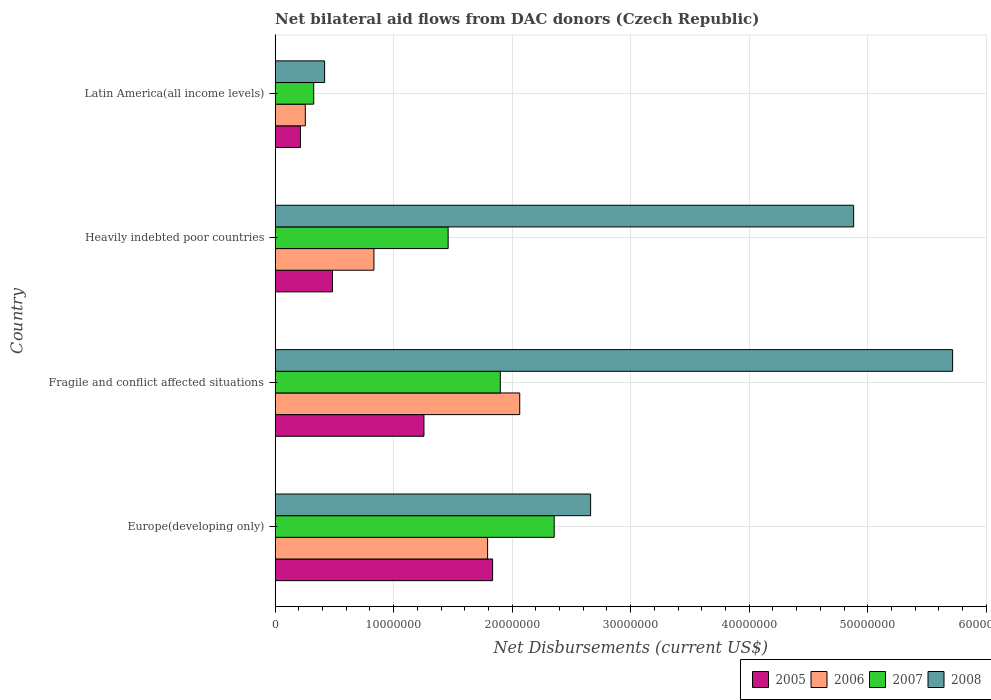Are the number of bars on each tick of the Y-axis equal?
Your answer should be very brief. Yes. How many bars are there on the 2nd tick from the top?
Your answer should be very brief. 4. How many bars are there on the 3rd tick from the bottom?
Your response must be concise. 4. What is the label of the 4th group of bars from the top?
Ensure brevity in your answer.  Europe(developing only). What is the net bilateral aid flows in 2005 in Fragile and conflict affected situations?
Make the answer very short. 1.26e+07. Across all countries, what is the maximum net bilateral aid flows in 2008?
Your response must be concise. 5.72e+07. Across all countries, what is the minimum net bilateral aid flows in 2006?
Your response must be concise. 2.55e+06. In which country was the net bilateral aid flows in 2007 maximum?
Make the answer very short. Europe(developing only). In which country was the net bilateral aid flows in 2007 minimum?
Offer a terse response. Latin America(all income levels). What is the total net bilateral aid flows in 2008 in the graph?
Provide a succinct answer. 1.37e+08. What is the difference between the net bilateral aid flows in 2005 in Fragile and conflict affected situations and that in Heavily indebted poor countries?
Keep it short and to the point. 7.72e+06. What is the difference between the net bilateral aid flows in 2005 in Heavily indebted poor countries and the net bilateral aid flows in 2008 in Fragile and conflict affected situations?
Offer a terse response. -5.23e+07. What is the average net bilateral aid flows in 2008 per country?
Offer a terse response. 3.42e+07. What is the difference between the net bilateral aid flows in 2007 and net bilateral aid flows in 2006 in Latin America(all income levels)?
Provide a succinct answer. 7.10e+05. What is the ratio of the net bilateral aid flows in 2007 in Europe(developing only) to that in Latin America(all income levels)?
Your response must be concise. 7.22. Is the net bilateral aid flows in 2008 in Fragile and conflict affected situations less than that in Latin America(all income levels)?
Ensure brevity in your answer.  No. What is the difference between the highest and the second highest net bilateral aid flows in 2007?
Make the answer very short. 4.55e+06. What is the difference between the highest and the lowest net bilateral aid flows in 2008?
Your answer should be compact. 5.30e+07. Is the sum of the net bilateral aid flows in 2005 in Fragile and conflict affected situations and Heavily indebted poor countries greater than the maximum net bilateral aid flows in 2007 across all countries?
Keep it short and to the point. No. Is it the case that in every country, the sum of the net bilateral aid flows in 2008 and net bilateral aid flows in 2007 is greater than the sum of net bilateral aid flows in 2005 and net bilateral aid flows in 2006?
Offer a very short reply. No. How many bars are there?
Ensure brevity in your answer.  16. Does the graph contain any zero values?
Your answer should be compact. No. Where does the legend appear in the graph?
Keep it short and to the point. Bottom right. How many legend labels are there?
Keep it short and to the point. 4. How are the legend labels stacked?
Provide a short and direct response. Horizontal. What is the title of the graph?
Offer a very short reply. Net bilateral aid flows from DAC donors (Czech Republic). Does "2008" appear as one of the legend labels in the graph?
Your answer should be very brief. Yes. What is the label or title of the X-axis?
Ensure brevity in your answer.  Net Disbursements (current US$). What is the Net Disbursements (current US$) in 2005 in Europe(developing only)?
Provide a succinct answer. 1.84e+07. What is the Net Disbursements (current US$) of 2006 in Europe(developing only)?
Provide a short and direct response. 1.79e+07. What is the Net Disbursements (current US$) in 2007 in Europe(developing only)?
Your answer should be compact. 2.36e+07. What is the Net Disbursements (current US$) of 2008 in Europe(developing only)?
Your answer should be very brief. 2.66e+07. What is the Net Disbursements (current US$) of 2005 in Fragile and conflict affected situations?
Your response must be concise. 1.26e+07. What is the Net Disbursements (current US$) of 2006 in Fragile and conflict affected situations?
Keep it short and to the point. 2.06e+07. What is the Net Disbursements (current US$) in 2007 in Fragile and conflict affected situations?
Provide a short and direct response. 1.90e+07. What is the Net Disbursements (current US$) in 2008 in Fragile and conflict affected situations?
Your answer should be compact. 5.72e+07. What is the Net Disbursements (current US$) of 2005 in Heavily indebted poor countries?
Ensure brevity in your answer.  4.84e+06. What is the Net Disbursements (current US$) of 2006 in Heavily indebted poor countries?
Ensure brevity in your answer.  8.34e+06. What is the Net Disbursements (current US$) of 2007 in Heavily indebted poor countries?
Your response must be concise. 1.46e+07. What is the Net Disbursements (current US$) in 2008 in Heavily indebted poor countries?
Keep it short and to the point. 4.88e+07. What is the Net Disbursements (current US$) of 2005 in Latin America(all income levels)?
Your response must be concise. 2.14e+06. What is the Net Disbursements (current US$) in 2006 in Latin America(all income levels)?
Offer a very short reply. 2.55e+06. What is the Net Disbursements (current US$) in 2007 in Latin America(all income levels)?
Ensure brevity in your answer.  3.26e+06. What is the Net Disbursements (current US$) of 2008 in Latin America(all income levels)?
Provide a succinct answer. 4.18e+06. Across all countries, what is the maximum Net Disbursements (current US$) in 2005?
Provide a succinct answer. 1.84e+07. Across all countries, what is the maximum Net Disbursements (current US$) of 2006?
Provide a succinct answer. 2.06e+07. Across all countries, what is the maximum Net Disbursements (current US$) in 2007?
Keep it short and to the point. 2.36e+07. Across all countries, what is the maximum Net Disbursements (current US$) of 2008?
Provide a short and direct response. 5.72e+07. Across all countries, what is the minimum Net Disbursements (current US$) of 2005?
Make the answer very short. 2.14e+06. Across all countries, what is the minimum Net Disbursements (current US$) in 2006?
Provide a short and direct response. 2.55e+06. Across all countries, what is the minimum Net Disbursements (current US$) of 2007?
Provide a short and direct response. 3.26e+06. Across all countries, what is the minimum Net Disbursements (current US$) in 2008?
Give a very brief answer. 4.18e+06. What is the total Net Disbursements (current US$) in 2005 in the graph?
Give a very brief answer. 3.79e+07. What is the total Net Disbursements (current US$) in 2006 in the graph?
Provide a succinct answer. 4.95e+07. What is the total Net Disbursements (current US$) in 2007 in the graph?
Provide a succinct answer. 6.04e+07. What is the total Net Disbursements (current US$) in 2008 in the graph?
Provide a succinct answer. 1.37e+08. What is the difference between the Net Disbursements (current US$) of 2005 in Europe(developing only) and that in Fragile and conflict affected situations?
Offer a terse response. 5.79e+06. What is the difference between the Net Disbursements (current US$) in 2006 in Europe(developing only) and that in Fragile and conflict affected situations?
Your answer should be compact. -2.71e+06. What is the difference between the Net Disbursements (current US$) in 2007 in Europe(developing only) and that in Fragile and conflict affected situations?
Your response must be concise. 4.55e+06. What is the difference between the Net Disbursements (current US$) of 2008 in Europe(developing only) and that in Fragile and conflict affected situations?
Keep it short and to the point. -3.05e+07. What is the difference between the Net Disbursements (current US$) in 2005 in Europe(developing only) and that in Heavily indebted poor countries?
Offer a very short reply. 1.35e+07. What is the difference between the Net Disbursements (current US$) in 2006 in Europe(developing only) and that in Heavily indebted poor countries?
Ensure brevity in your answer.  9.59e+06. What is the difference between the Net Disbursements (current US$) of 2007 in Europe(developing only) and that in Heavily indebted poor countries?
Provide a succinct answer. 8.95e+06. What is the difference between the Net Disbursements (current US$) in 2008 in Europe(developing only) and that in Heavily indebted poor countries?
Your answer should be compact. -2.22e+07. What is the difference between the Net Disbursements (current US$) of 2005 in Europe(developing only) and that in Latin America(all income levels)?
Ensure brevity in your answer.  1.62e+07. What is the difference between the Net Disbursements (current US$) of 2006 in Europe(developing only) and that in Latin America(all income levels)?
Provide a succinct answer. 1.54e+07. What is the difference between the Net Disbursements (current US$) of 2007 in Europe(developing only) and that in Latin America(all income levels)?
Your answer should be compact. 2.03e+07. What is the difference between the Net Disbursements (current US$) of 2008 in Europe(developing only) and that in Latin America(all income levels)?
Keep it short and to the point. 2.24e+07. What is the difference between the Net Disbursements (current US$) in 2005 in Fragile and conflict affected situations and that in Heavily indebted poor countries?
Ensure brevity in your answer.  7.72e+06. What is the difference between the Net Disbursements (current US$) of 2006 in Fragile and conflict affected situations and that in Heavily indebted poor countries?
Make the answer very short. 1.23e+07. What is the difference between the Net Disbursements (current US$) of 2007 in Fragile and conflict affected situations and that in Heavily indebted poor countries?
Provide a succinct answer. 4.40e+06. What is the difference between the Net Disbursements (current US$) in 2008 in Fragile and conflict affected situations and that in Heavily indebted poor countries?
Give a very brief answer. 8.35e+06. What is the difference between the Net Disbursements (current US$) in 2005 in Fragile and conflict affected situations and that in Latin America(all income levels)?
Provide a short and direct response. 1.04e+07. What is the difference between the Net Disbursements (current US$) in 2006 in Fragile and conflict affected situations and that in Latin America(all income levels)?
Provide a short and direct response. 1.81e+07. What is the difference between the Net Disbursements (current US$) in 2007 in Fragile and conflict affected situations and that in Latin America(all income levels)?
Keep it short and to the point. 1.57e+07. What is the difference between the Net Disbursements (current US$) of 2008 in Fragile and conflict affected situations and that in Latin America(all income levels)?
Offer a terse response. 5.30e+07. What is the difference between the Net Disbursements (current US$) of 2005 in Heavily indebted poor countries and that in Latin America(all income levels)?
Offer a very short reply. 2.70e+06. What is the difference between the Net Disbursements (current US$) of 2006 in Heavily indebted poor countries and that in Latin America(all income levels)?
Offer a terse response. 5.79e+06. What is the difference between the Net Disbursements (current US$) in 2007 in Heavily indebted poor countries and that in Latin America(all income levels)?
Keep it short and to the point. 1.13e+07. What is the difference between the Net Disbursements (current US$) of 2008 in Heavily indebted poor countries and that in Latin America(all income levels)?
Offer a terse response. 4.46e+07. What is the difference between the Net Disbursements (current US$) of 2005 in Europe(developing only) and the Net Disbursements (current US$) of 2006 in Fragile and conflict affected situations?
Your answer should be very brief. -2.29e+06. What is the difference between the Net Disbursements (current US$) in 2005 in Europe(developing only) and the Net Disbursements (current US$) in 2007 in Fragile and conflict affected situations?
Make the answer very short. -6.50e+05. What is the difference between the Net Disbursements (current US$) of 2005 in Europe(developing only) and the Net Disbursements (current US$) of 2008 in Fragile and conflict affected situations?
Your answer should be very brief. -3.88e+07. What is the difference between the Net Disbursements (current US$) in 2006 in Europe(developing only) and the Net Disbursements (current US$) in 2007 in Fragile and conflict affected situations?
Make the answer very short. -1.07e+06. What is the difference between the Net Disbursements (current US$) in 2006 in Europe(developing only) and the Net Disbursements (current US$) in 2008 in Fragile and conflict affected situations?
Provide a short and direct response. -3.92e+07. What is the difference between the Net Disbursements (current US$) in 2007 in Europe(developing only) and the Net Disbursements (current US$) in 2008 in Fragile and conflict affected situations?
Provide a succinct answer. -3.36e+07. What is the difference between the Net Disbursements (current US$) of 2005 in Europe(developing only) and the Net Disbursements (current US$) of 2006 in Heavily indebted poor countries?
Your answer should be compact. 1.00e+07. What is the difference between the Net Disbursements (current US$) in 2005 in Europe(developing only) and the Net Disbursements (current US$) in 2007 in Heavily indebted poor countries?
Your answer should be compact. 3.75e+06. What is the difference between the Net Disbursements (current US$) of 2005 in Europe(developing only) and the Net Disbursements (current US$) of 2008 in Heavily indebted poor countries?
Give a very brief answer. -3.05e+07. What is the difference between the Net Disbursements (current US$) of 2006 in Europe(developing only) and the Net Disbursements (current US$) of 2007 in Heavily indebted poor countries?
Offer a very short reply. 3.33e+06. What is the difference between the Net Disbursements (current US$) in 2006 in Europe(developing only) and the Net Disbursements (current US$) in 2008 in Heavily indebted poor countries?
Ensure brevity in your answer.  -3.09e+07. What is the difference between the Net Disbursements (current US$) of 2007 in Europe(developing only) and the Net Disbursements (current US$) of 2008 in Heavily indebted poor countries?
Give a very brief answer. -2.53e+07. What is the difference between the Net Disbursements (current US$) in 2005 in Europe(developing only) and the Net Disbursements (current US$) in 2006 in Latin America(all income levels)?
Provide a short and direct response. 1.58e+07. What is the difference between the Net Disbursements (current US$) in 2005 in Europe(developing only) and the Net Disbursements (current US$) in 2007 in Latin America(all income levels)?
Offer a terse response. 1.51e+07. What is the difference between the Net Disbursements (current US$) of 2005 in Europe(developing only) and the Net Disbursements (current US$) of 2008 in Latin America(all income levels)?
Give a very brief answer. 1.42e+07. What is the difference between the Net Disbursements (current US$) of 2006 in Europe(developing only) and the Net Disbursements (current US$) of 2007 in Latin America(all income levels)?
Give a very brief answer. 1.47e+07. What is the difference between the Net Disbursements (current US$) in 2006 in Europe(developing only) and the Net Disbursements (current US$) in 2008 in Latin America(all income levels)?
Give a very brief answer. 1.38e+07. What is the difference between the Net Disbursements (current US$) of 2007 in Europe(developing only) and the Net Disbursements (current US$) of 2008 in Latin America(all income levels)?
Make the answer very short. 1.94e+07. What is the difference between the Net Disbursements (current US$) in 2005 in Fragile and conflict affected situations and the Net Disbursements (current US$) in 2006 in Heavily indebted poor countries?
Offer a very short reply. 4.22e+06. What is the difference between the Net Disbursements (current US$) in 2005 in Fragile and conflict affected situations and the Net Disbursements (current US$) in 2007 in Heavily indebted poor countries?
Your response must be concise. -2.04e+06. What is the difference between the Net Disbursements (current US$) in 2005 in Fragile and conflict affected situations and the Net Disbursements (current US$) in 2008 in Heavily indebted poor countries?
Keep it short and to the point. -3.62e+07. What is the difference between the Net Disbursements (current US$) of 2006 in Fragile and conflict affected situations and the Net Disbursements (current US$) of 2007 in Heavily indebted poor countries?
Ensure brevity in your answer.  6.04e+06. What is the difference between the Net Disbursements (current US$) of 2006 in Fragile and conflict affected situations and the Net Disbursements (current US$) of 2008 in Heavily indebted poor countries?
Your response must be concise. -2.82e+07. What is the difference between the Net Disbursements (current US$) of 2007 in Fragile and conflict affected situations and the Net Disbursements (current US$) of 2008 in Heavily indebted poor countries?
Make the answer very short. -2.98e+07. What is the difference between the Net Disbursements (current US$) of 2005 in Fragile and conflict affected situations and the Net Disbursements (current US$) of 2006 in Latin America(all income levels)?
Keep it short and to the point. 1.00e+07. What is the difference between the Net Disbursements (current US$) of 2005 in Fragile and conflict affected situations and the Net Disbursements (current US$) of 2007 in Latin America(all income levels)?
Offer a terse response. 9.30e+06. What is the difference between the Net Disbursements (current US$) of 2005 in Fragile and conflict affected situations and the Net Disbursements (current US$) of 2008 in Latin America(all income levels)?
Your answer should be very brief. 8.38e+06. What is the difference between the Net Disbursements (current US$) in 2006 in Fragile and conflict affected situations and the Net Disbursements (current US$) in 2007 in Latin America(all income levels)?
Your answer should be very brief. 1.74e+07. What is the difference between the Net Disbursements (current US$) in 2006 in Fragile and conflict affected situations and the Net Disbursements (current US$) in 2008 in Latin America(all income levels)?
Provide a succinct answer. 1.65e+07. What is the difference between the Net Disbursements (current US$) of 2007 in Fragile and conflict affected situations and the Net Disbursements (current US$) of 2008 in Latin America(all income levels)?
Offer a very short reply. 1.48e+07. What is the difference between the Net Disbursements (current US$) in 2005 in Heavily indebted poor countries and the Net Disbursements (current US$) in 2006 in Latin America(all income levels)?
Offer a terse response. 2.29e+06. What is the difference between the Net Disbursements (current US$) of 2005 in Heavily indebted poor countries and the Net Disbursements (current US$) of 2007 in Latin America(all income levels)?
Give a very brief answer. 1.58e+06. What is the difference between the Net Disbursements (current US$) of 2005 in Heavily indebted poor countries and the Net Disbursements (current US$) of 2008 in Latin America(all income levels)?
Ensure brevity in your answer.  6.60e+05. What is the difference between the Net Disbursements (current US$) of 2006 in Heavily indebted poor countries and the Net Disbursements (current US$) of 2007 in Latin America(all income levels)?
Make the answer very short. 5.08e+06. What is the difference between the Net Disbursements (current US$) of 2006 in Heavily indebted poor countries and the Net Disbursements (current US$) of 2008 in Latin America(all income levels)?
Provide a succinct answer. 4.16e+06. What is the difference between the Net Disbursements (current US$) in 2007 in Heavily indebted poor countries and the Net Disbursements (current US$) in 2008 in Latin America(all income levels)?
Provide a short and direct response. 1.04e+07. What is the average Net Disbursements (current US$) in 2005 per country?
Provide a succinct answer. 9.47e+06. What is the average Net Disbursements (current US$) in 2006 per country?
Ensure brevity in your answer.  1.24e+07. What is the average Net Disbursements (current US$) of 2007 per country?
Keep it short and to the point. 1.51e+07. What is the average Net Disbursements (current US$) in 2008 per country?
Your answer should be very brief. 3.42e+07. What is the difference between the Net Disbursements (current US$) of 2005 and Net Disbursements (current US$) of 2006 in Europe(developing only)?
Ensure brevity in your answer.  4.20e+05. What is the difference between the Net Disbursements (current US$) of 2005 and Net Disbursements (current US$) of 2007 in Europe(developing only)?
Offer a very short reply. -5.20e+06. What is the difference between the Net Disbursements (current US$) in 2005 and Net Disbursements (current US$) in 2008 in Europe(developing only)?
Offer a very short reply. -8.27e+06. What is the difference between the Net Disbursements (current US$) in 2006 and Net Disbursements (current US$) in 2007 in Europe(developing only)?
Provide a short and direct response. -5.62e+06. What is the difference between the Net Disbursements (current US$) of 2006 and Net Disbursements (current US$) of 2008 in Europe(developing only)?
Your answer should be very brief. -8.69e+06. What is the difference between the Net Disbursements (current US$) of 2007 and Net Disbursements (current US$) of 2008 in Europe(developing only)?
Provide a short and direct response. -3.07e+06. What is the difference between the Net Disbursements (current US$) in 2005 and Net Disbursements (current US$) in 2006 in Fragile and conflict affected situations?
Ensure brevity in your answer.  -8.08e+06. What is the difference between the Net Disbursements (current US$) of 2005 and Net Disbursements (current US$) of 2007 in Fragile and conflict affected situations?
Provide a short and direct response. -6.44e+06. What is the difference between the Net Disbursements (current US$) of 2005 and Net Disbursements (current US$) of 2008 in Fragile and conflict affected situations?
Your response must be concise. -4.46e+07. What is the difference between the Net Disbursements (current US$) in 2006 and Net Disbursements (current US$) in 2007 in Fragile and conflict affected situations?
Make the answer very short. 1.64e+06. What is the difference between the Net Disbursements (current US$) in 2006 and Net Disbursements (current US$) in 2008 in Fragile and conflict affected situations?
Provide a short and direct response. -3.65e+07. What is the difference between the Net Disbursements (current US$) in 2007 and Net Disbursements (current US$) in 2008 in Fragile and conflict affected situations?
Provide a short and direct response. -3.82e+07. What is the difference between the Net Disbursements (current US$) in 2005 and Net Disbursements (current US$) in 2006 in Heavily indebted poor countries?
Keep it short and to the point. -3.50e+06. What is the difference between the Net Disbursements (current US$) in 2005 and Net Disbursements (current US$) in 2007 in Heavily indebted poor countries?
Keep it short and to the point. -9.76e+06. What is the difference between the Net Disbursements (current US$) in 2005 and Net Disbursements (current US$) in 2008 in Heavily indebted poor countries?
Your response must be concise. -4.40e+07. What is the difference between the Net Disbursements (current US$) of 2006 and Net Disbursements (current US$) of 2007 in Heavily indebted poor countries?
Your answer should be compact. -6.26e+06. What is the difference between the Net Disbursements (current US$) in 2006 and Net Disbursements (current US$) in 2008 in Heavily indebted poor countries?
Give a very brief answer. -4.05e+07. What is the difference between the Net Disbursements (current US$) of 2007 and Net Disbursements (current US$) of 2008 in Heavily indebted poor countries?
Provide a short and direct response. -3.42e+07. What is the difference between the Net Disbursements (current US$) in 2005 and Net Disbursements (current US$) in 2006 in Latin America(all income levels)?
Provide a succinct answer. -4.10e+05. What is the difference between the Net Disbursements (current US$) of 2005 and Net Disbursements (current US$) of 2007 in Latin America(all income levels)?
Give a very brief answer. -1.12e+06. What is the difference between the Net Disbursements (current US$) of 2005 and Net Disbursements (current US$) of 2008 in Latin America(all income levels)?
Provide a short and direct response. -2.04e+06. What is the difference between the Net Disbursements (current US$) of 2006 and Net Disbursements (current US$) of 2007 in Latin America(all income levels)?
Ensure brevity in your answer.  -7.10e+05. What is the difference between the Net Disbursements (current US$) in 2006 and Net Disbursements (current US$) in 2008 in Latin America(all income levels)?
Provide a short and direct response. -1.63e+06. What is the difference between the Net Disbursements (current US$) in 2007 and Net Disbursements (current US$) in 2008 in Latin America(all income levels)?
Keep it short and to the point. -9.20e+05. What is the ratio of the Net Disbursements (current US$) in 2005 in Europe(developing only) to that in Fragile and conflict affected situations?
Provide a succinct answer. 1.46. What is the ratio of the Net Disbursements (current US$) of 2006 in Europe(developing only) to that in Fragile and conflict affected situations?
Make the answer very short. 0.87. What is the ratio of the Net Disbursements (current US$) of 2007 in Europe(developing only) to that in Fragile and conflict affected situations?
Offer a terse response. 1.24. What is the ratio of the Net Disbursements (current US$) of 2008 in Europe(developing only) to that in Fragile and conflict affected situations?
Provide a succinct answer. 0.47. What is the ratio of the Net Disbursements (current US$) of 2005 in Europe(developing only) to that in Heavily indebted poor countries?
Offer a very short reply. 3.79. What is the ratio of the Net Disbursements (current US$) of 2006 in Europe(developing only) to that in Heavily indebted poor countries?
Your response must be concise. 2.15. What is the ratio of the Net Disbursements (current US$) of 2007 in Europe(developing only) to that in Heavily indebted poor countries?
Offer a very short reply. 1.61. What is the ratio of the Net Disbursements (current US$) in 2008 in Europe(developing only) to that in Heavily indebted poor countries?
Keep it short and to the point. 0.55. What is the ratio of the Net Disbursements (current US$) in 2005 in Europe(developing only) to that in Latin America(all income levels)?
Offer a very short reply. 8.57. What is the ratio of the Net Disbursements (current US$) in 2006 in Europe(developing only) to that in Latin America(all income levels)?
Keep it short and to the point. 7.03. What is the ratio of the Net Disbursements (current US$) in 2007 in Europe(developing only) to that in Latin America(all income levels)?
Provide a succinct answer. 7.22. What is the ratio of the Net Disbursements (current US$) in 2008 in Europe(developing only) to that in Latin America(all income levels)?
Provide a succinct answer. 6.37. What is the ratio of the Net Disbursements (current US$) in 2005 in Fragile and conflict affected situations to that in Heavily indebted poor countries?
Make the answer very short. 2.6. What is the ratio of the Net Disbursements (current US$) of 2006 in Fragile and conflict affected situations to that in Heavily indebted poor countries?
Provide a succinct answer. 2.47. What is the ratio of the Net Disbursements (current US$) of 2007 in Fragile and conflict affected situations to that in Heavily indebted poor countries?
Your answer should be compact. 1.3. What is the ratio of the Net Disbursements (current US$) in 2008 in Fragile and conflict affected situations to that in Heavily indebted poor countries?
Your answer should be compact. 1.17. What is the ratio of the Net Disbursements (current US$) in 2005 in Fragile and conflict affected situations to that in Latin America(all income levels)?
Provide a succinct answer. 5.87. What is the ratio of the Net Disbursements (current US$) in 2006 in Fragile and conflict affected situations to that in Latin America(all income levels)?
Keep it short and to the point. 8.09. What is the ratio of the Net Disbursements (current US$) of 2007 in Fragile and conflict affected situations to that in Latin America(all income levels)?
Ensure brevity in your answer.  5.83. What is the ratio of the Net Disbursements (current US$) in 2008 in Fragile and conflict affected situations to that in Latin America(all income levels)?
Offer a terse response. 13.67. What is the ratio of the Net Disbursements (current US$) of 2005 in Heavily indebted poor countries to that in Latin America(all income levels)?
Ensure brevity in your answer.  2.26. What is the ratio of the Net Disbursements (current US$) of 2006 in Heavily indebted poor countries to that in Latin America(all income levels)?
Keep it short and to the point. 3.27. What is the ratio of the Net Disbursements (current US$) of 2007 in Heavily indebted poor countries to that in Latin America(all income levels)?
Your answer should be compact. 4.48. What is the ratio of the Net Disbursements (current US$) in 2008 in Heavily indebted poor countries to that in Latin America(all income levels)?
Ensure brevity in your answer.  11.68. What is the difference between the highest and the second highest Net Disbursements (current US$) of 2005?
Provide a succinct answer. 5.79e+06. What is the difference between the highest and the second highest Net Disbursements (current US$) of 2006?
Give a very brief answer. 2.71e+06. What is the difference between the highest and the second highest Net Disbursements (current US$) of 2007?
Provide a succinct answer. 4.55e+06. What is the difference between the highest and the second highest Net Disbursements (current US$) in 2008?
Your answer should be compact. 8.35e+06. What is the difference between the highest and the lowest Net Disbursements (current US$) in 2005?
Your answer should be compact. 1.62e+07. What is the difference between the highest and the lowest Net Disbursements (current US$) in 2006?
Provide a short and direct response. 1.81e+07. What is the difference between the highest and the lowest Net Disbursements (current US$) in 2007?
Keep it short and to the point. 2.03e+07. What is the difference between the highest and the lowest Net Disbursements (current US$) of 2008?
Offer a terse response. 5.30e+07. 